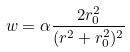Convert formula to latex. <formula><loc_0><loc_0><loc_500><loc_500>\ w = \alpha \frac { 2 r ^ { 2 } _ { 0 } } { ( r ^ { 2 } + r ^ { 2 } _ { 0 } ) ^ { 2 } }</formula> 